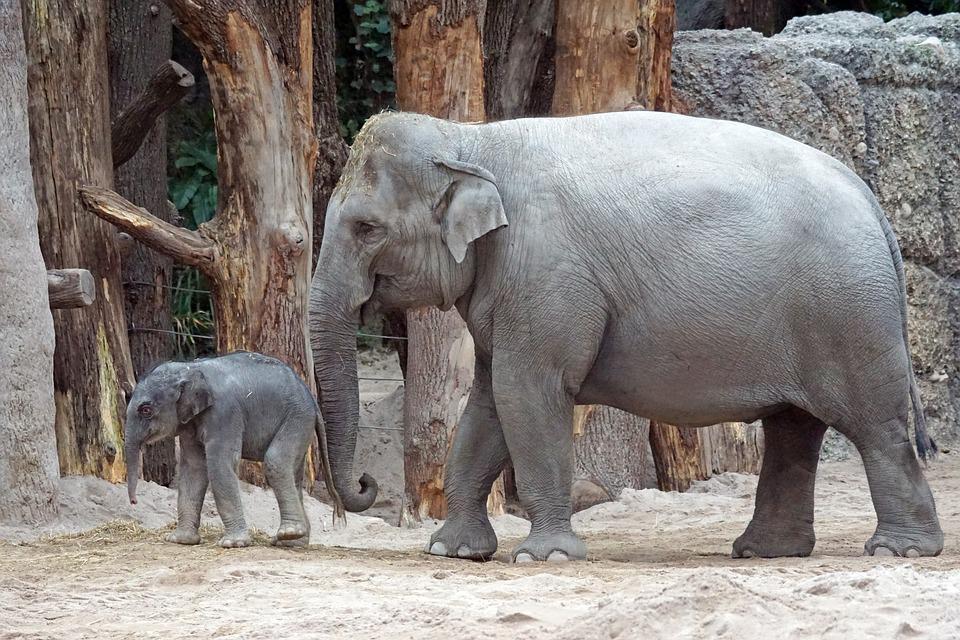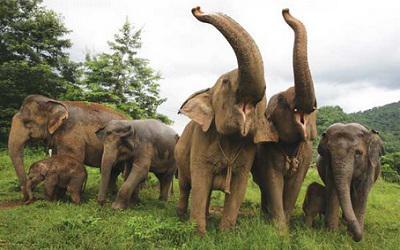The first image is the image on the left, the second image is the image on the right. For the images shown, is this caption "One image shows one gray baby elephant walking with no more than three adults." true? Answer yes or no. Yes. The first image is the image on the left, the second image is the image on the right. Considering the images on both sides, is "All elephants are headed in the same direction." valid? Answer yes or no. No. 